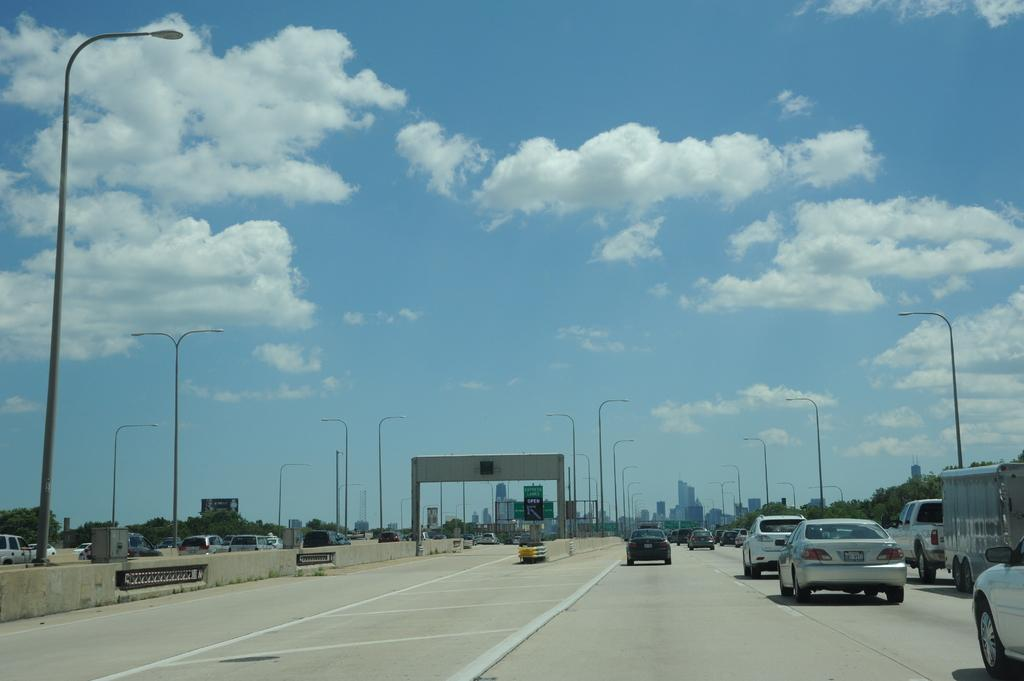What type of structures can be seen in the image? There are buildings in the image. What else is present in the image besides buildings? There are vehicles, poles, trees, boards, and an arch visible in the image. What is the ground like in the image? The ground is visible in the image. What can be seen in the sky in the image? The sky is visible in the image, and there are clouds present. How many apples are hanging from the trees in the image? There are no apples present in the image; only trees are visible. What type of home is shown in the image? There is no home depicted in the image; only buildings, vehicles, poles, trees, boards, an arch, and the sky are present. 